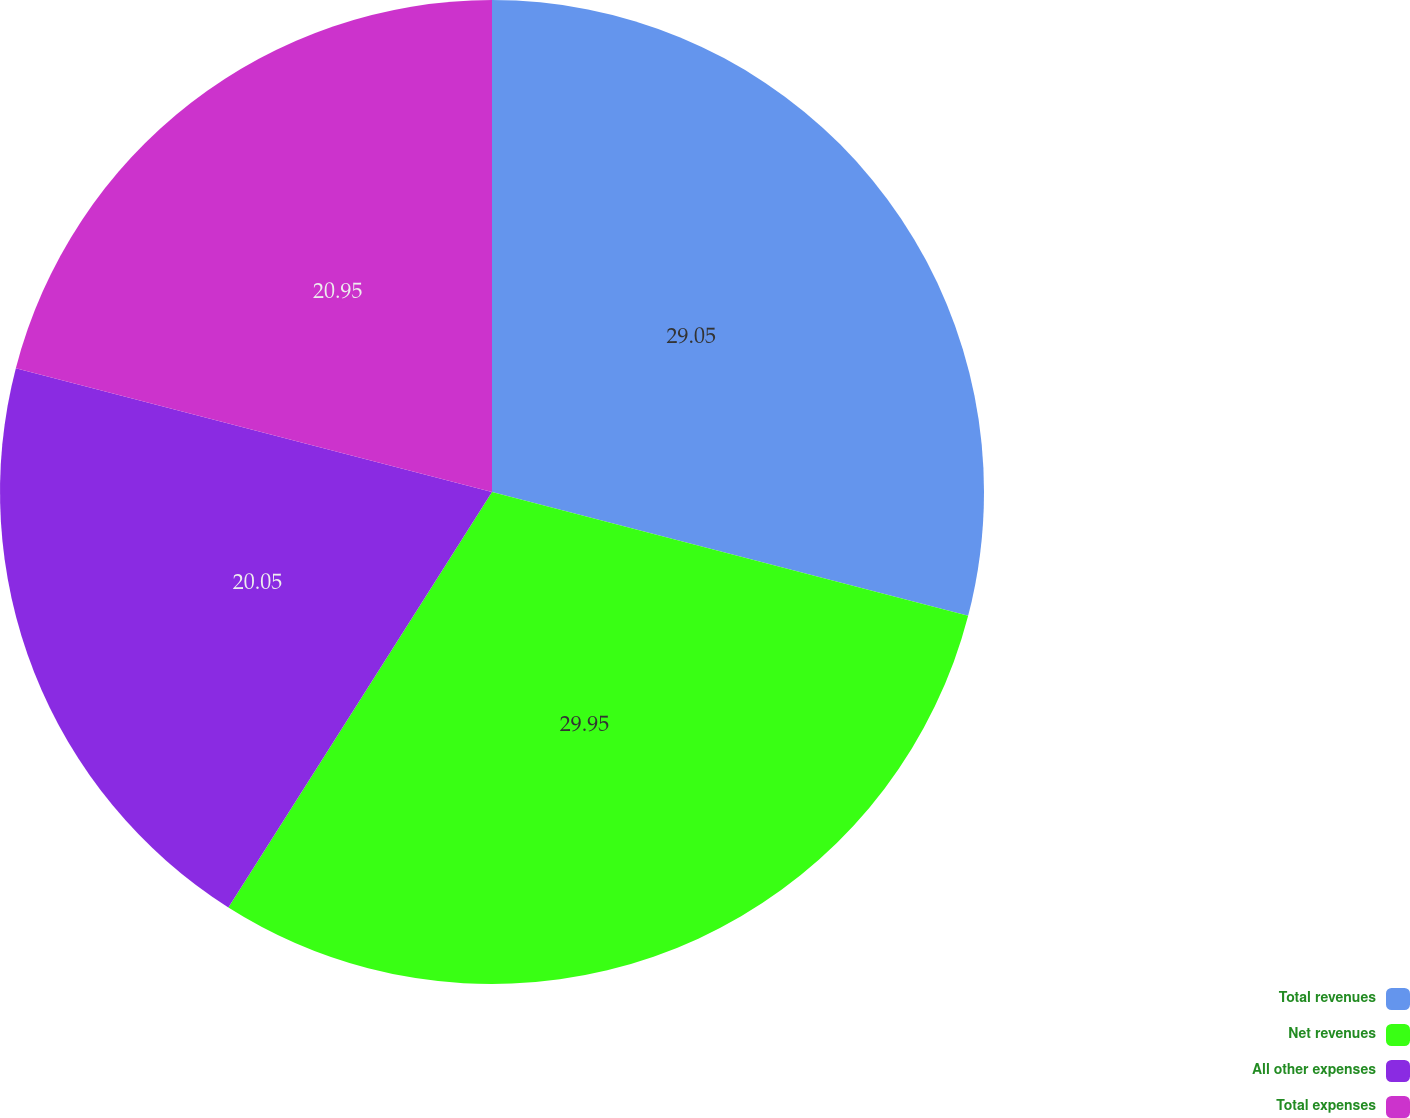<chart> <loc_0><loc_0><loc_500><loc_500><pie_chart><fcel>Total revenues<fcel>Net revenues<fcel>All other expenses<fcel>Total expenses<nl><fcel>29.05%<fcel>29.95%<fcel>20.05%<fcel>20.95%<nl></chart> 